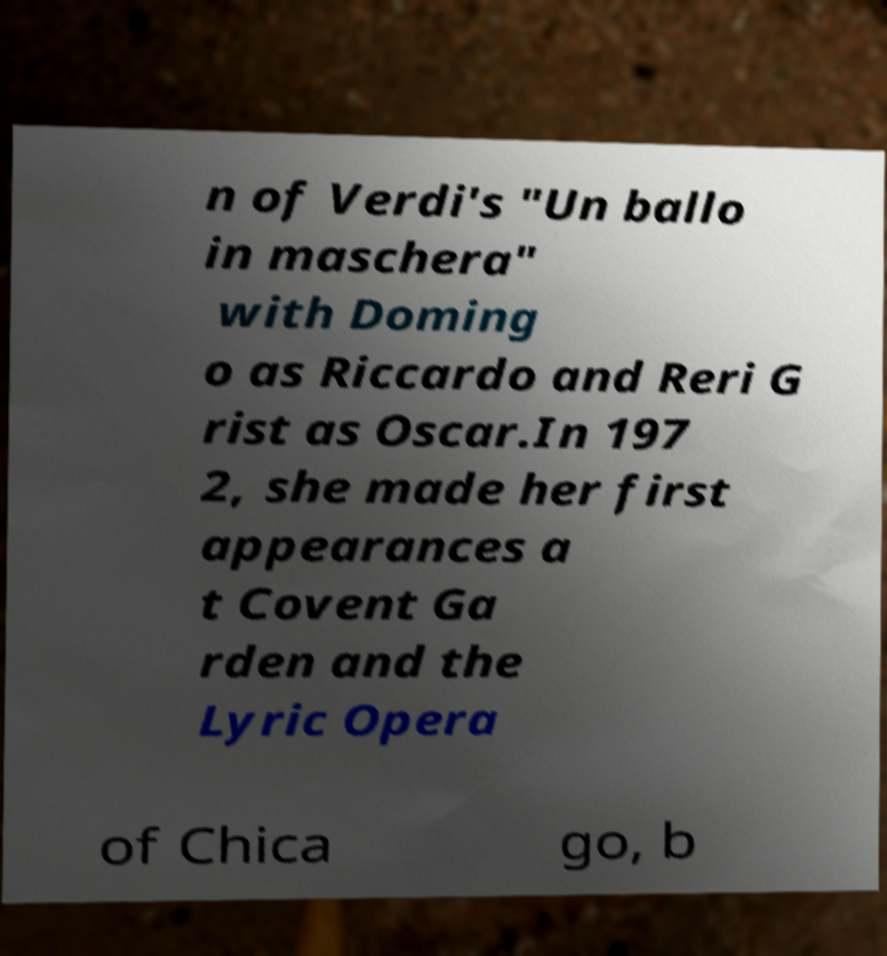For documentation purposes, I need the text within this image transcribed. Could you provide that? n of Verdi's "Un ballo in maschera" with Doming o as Riccardo and Reri G rist as Oscar.In 197 2, she made her first appearances a t Covent Ga rden and the Lyric Opera of Chica go, b 